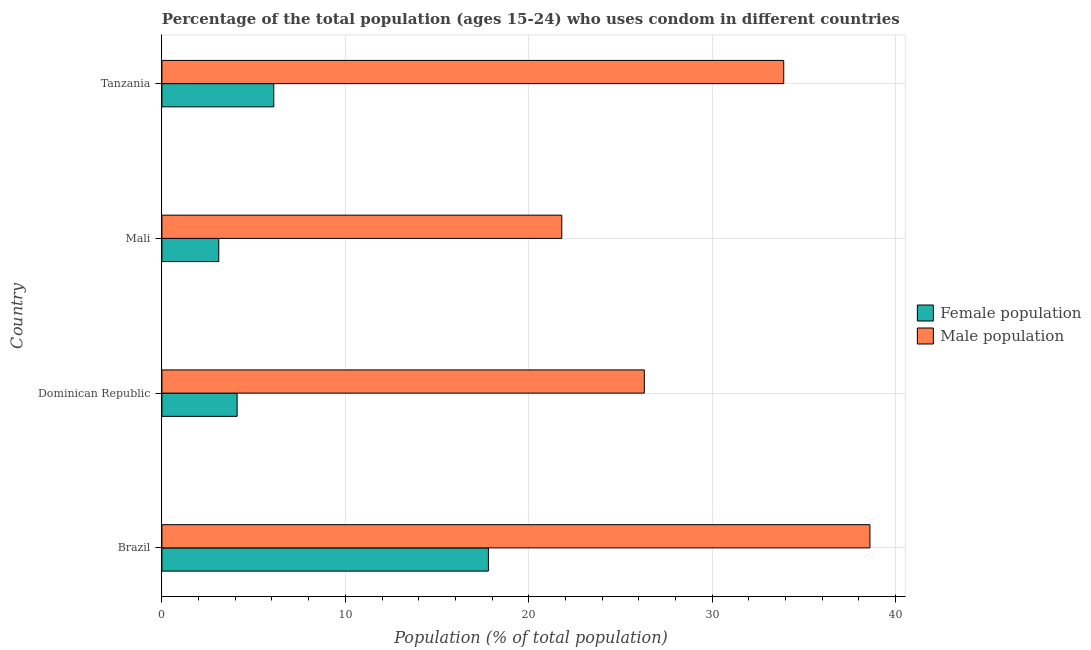How many groups of bars are there?
Keep it short and to the point. 4. How many bars are there on the 2nd tick from the top?
Give a very brief answer. 2. How many bars are there on the 1st tick from the bottom?
Provide a short and direct response. 2. What is the label of the 4th group of bars from the top?
Your answer should be compact. Brazil. What is the male population in Brazil?
Offer a very short reply. 38.6. Across all countries, what is the maximum female population?
Provide a succinct answer. 17.8. In which country was the male population maximum?
Provide a short and direct response. Brazil. In which country was the female population minimum?
Provide a short and direct response. Mali. What is the total male population in the graph?
Your response must be concise. 120.6. What is the difference between the female population in Brazil and that in Tanzania?
Give a very brief answer. 11.7. What is the difference between the male population in Mali and the female population in Dominican Republic?
Make the answer very short. 17.7. What is the average male population per country?
Offer a terse response. 30.15. What is the difference between the female population and male population in Brazil?
Make the answer very short. -20.8. What is the ratio of the male population in Dominican Republic to that in Mali?
Make the answer very short. 1.21. Is the female population in Dominican Republic less than that in Mali?
Keep it short and to the point. No. Is the difference between the male population in Mali and Tanzania greater than the difference between the female population in Mali and Tanzania?
Provide a succinct answer. No. What is the difference between the highest and the lowest female population?
Give a very brief answer. 14.7. In how many countries, is the male population greater than the average male population taken over all countries?
Make the answer very short. 2. Is the sum of the female population in Brazil and Dominican Republic greater than the maximum male population across all countries?
Your answer should be very brief. No. What does the 2nd bar from the top in Mali represents?
Offer a terse response. Female population. What does the 1st bar from the bottom in Mali represents?
Make the answer very short. Female population. How many bars are there?
Provide a succinct answer. 8. Are all the bars in the graph horizontal?
Your answer should be compact. Yes. What is the difference between two consecutive major ticks on the X-axis?
Offer a terse response. 10. Does the graph contain any zero values?
Your answer should be compact. No. Where does the legend appear in the graph?
Offer a very short reply. Center right. How are the legend labels stacked?
Your answer should be compact. Vertical. What is the title of the graph?
Give a very brief answer. Percentage of the total population (ages 15-24) who uses condom in different countries. What is the label or title of the X-axis?
Provide a succinct answer. Population (% of total population) . What is the label or title of the Y-axis?
Give a very brief answer. Country. What is the Population (% of total population)  in Female population in Brazil?
Provide a short and direct response. 17.8. What is the Population (% of total population)  in Male population in Brazil?
Provide a short and direct response. 38.6. What is the Population (% of total population)  of Female population in Dominican Republic?
Give a very brief answer. 4.1. What is the Population (% of total population)  in Male population in Dominican Republic?
Provide a succinct answer. 26.3. What is the Population (% of total population)  in Male population in Mali?
Your response must be concise. 21.8. What is the Population (% of total population)  in Female population in Tanzania?
Provide a succinct answer. 6.1. What is the Population (% of total population)  of Male population in Tanzania?
Offer a terse response. 33.9. Across all countries, what is the maximum Population (% of total population)  in Male population?
Your answer should be very brief. 38.6. Across all countries, what is the minimum Population (% of total population)  of Female population?
Keep it short and to the point. 3.1. Across all countries, what is the minimum Population (% of total population)  in Male population?
Offer a very short reply. 21.8. What is the total Population (% of total population)  in Female population in the graph?
Keep it short and to the point. 31.1. What is the total Population (% of total population)  of Male population in the graph?
Give a very brief answer. 120.6. What is the difference between the Population (% of total population)  of Female population in Brazil and that in Tanzania?
Give a very brief answer. 11.7. What is the difference between the Population (% of total population)  of Female population in Dominican Republic and that in Mali?
Give a very brief answer. 1. What is the difference between the Population (% of total population)  in Female population in Dominican Republic and that in Tanzania?
Provide a succinct answer. -2. What is the difference between the Population (% of total population)  of Male population in Dominican Republic and that in Tanzania?
Give a very brief answer. -7.6. What is the difference between the Population (% of total population)  of Male population in Mali and that in Tanzania?
Provide a short and direct response. -12.1. What is the difference between the Population (% of total population)  in Female population in Brazil and the Population (% of total population)  in Male population in Dominican Republic?
Your response must be concise. -8.5. What is the difference between the Population (% of total population)  of Female population in Brazil and the Population (% of total population)  of Male population in Mali?
Your response must be concise. -4. What is the difference between the Population (% of total population)  of Female population in Brazil and the Population (% of total population)  of Male population in Tanzania?
Make the answer very short. -16.1. What is the difference between the Population (% of total population)  of Female population in Dominican Republic and the Population (% of total population)  of Male population in Mali?
Your answer should be very brief. -17.7. What is the difference between the Population (% of total population)  in Female population in Dominican Republic and the Population (% of total population)  in Male population in Tanzania?
Your response must be concise. -29.8. What is the difference between the Population (% of total population)  of Female population in Mali and the Population (% of total population)  of Male population in Tanzania?
Provide a short and direct response. -30.8. What is the average Population (% of total population)  of Female population per country?
Offer a very short reply. 7.78. What is the average Population (% of total population)  of Male population per country?
Keep it short and to the point. 30.15. What is the difference between the Population (% of total population)  in Female population and Population (% of total population)  in Male population in Brazil?
Provide a short and direct response. -20.8. What is the difference between the Population (% of total population)  in Female population and Population (% of total population)  in Male population in Dominican Republic?
Keep it short and to the point. -22.2. What is the difference between the Population (% of total population)  of Female population and Population (% of total population)  of Male population in Mali?
Give a very brief answer. -18.7. What is the difference between the Population (% of total population)  in Female population and Population (% of total population)  in Male population in Tanzania?
Offer a terse response. -27.8. What is the ratio of the Population (% of total population)  in Female population in Brazil to that in Dominican Republic?
Keep it short and to the point. 4.34. What is the ratio of the Population (% of total population)  of Male population in Brazil to that in Dominican Republic?
Give a very brief answer. 1.47. What is the ratio of the Population (% of total population)  in Female population in Brazil to that in Mali?
Make the answer very short. 5.74. What is the ratio of the Population (% of total population)  of Male population in Brazil to that in Mali?
Provide a short and direct response. 1.77. What is the ratio of the Population (% of total population)  of Female population in Brazil to that in Tanzania?
Offer a very short reply. 2.92. What is the ratio of the Population (% of total population)  in Male population in Brazil to that in Tanzania?
Provide a short and direct response. 1.14. What is the ratio of the Population (% of total population)  in Female population in Dominican Republic to that in Mali?
Make the answer very short. 1.32. What is the ratio of the Population (% of total population)  in Male population in Dominican Republic to that in Mali?
Keep it short and to the point. 1.21. What is the ratio of the Population (% of total population)  in Female population in Dominican Republic to that in Tanzania?
Keep it short and to the point. 0.67. What is the ratio of the Population (% of total population)  of Male population in Dominican Republic to that in Tanzania?
Provide a short and direct response. 0.78. What is the ratio of the Population (% of total population)  in Female population in Mali to that in Tanzania?
Provide a succinct answer. 0.51. What is the ratio of the Population (% of total population)  in Male population in Mali to that in Tanzania?
Your response must be concise. 0.64. What is the difference between the highest and the second highest Population (% of total population)  in Female population?
Offer a terse response. 11.7. 